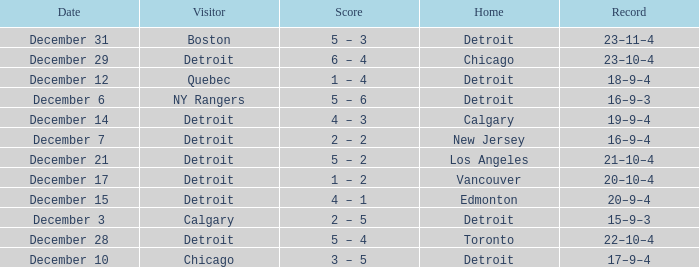Who will be the guest on december 3rd? Calgary. 